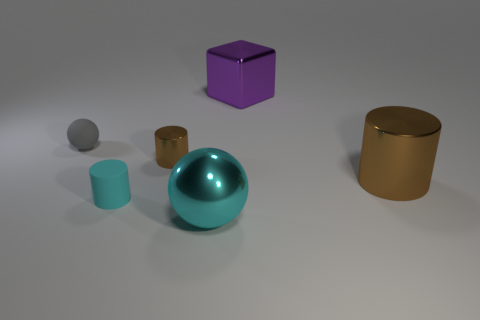How many objects are either matte things in front of the big brown metallic cylinder or tiny rubber spheres? 2 